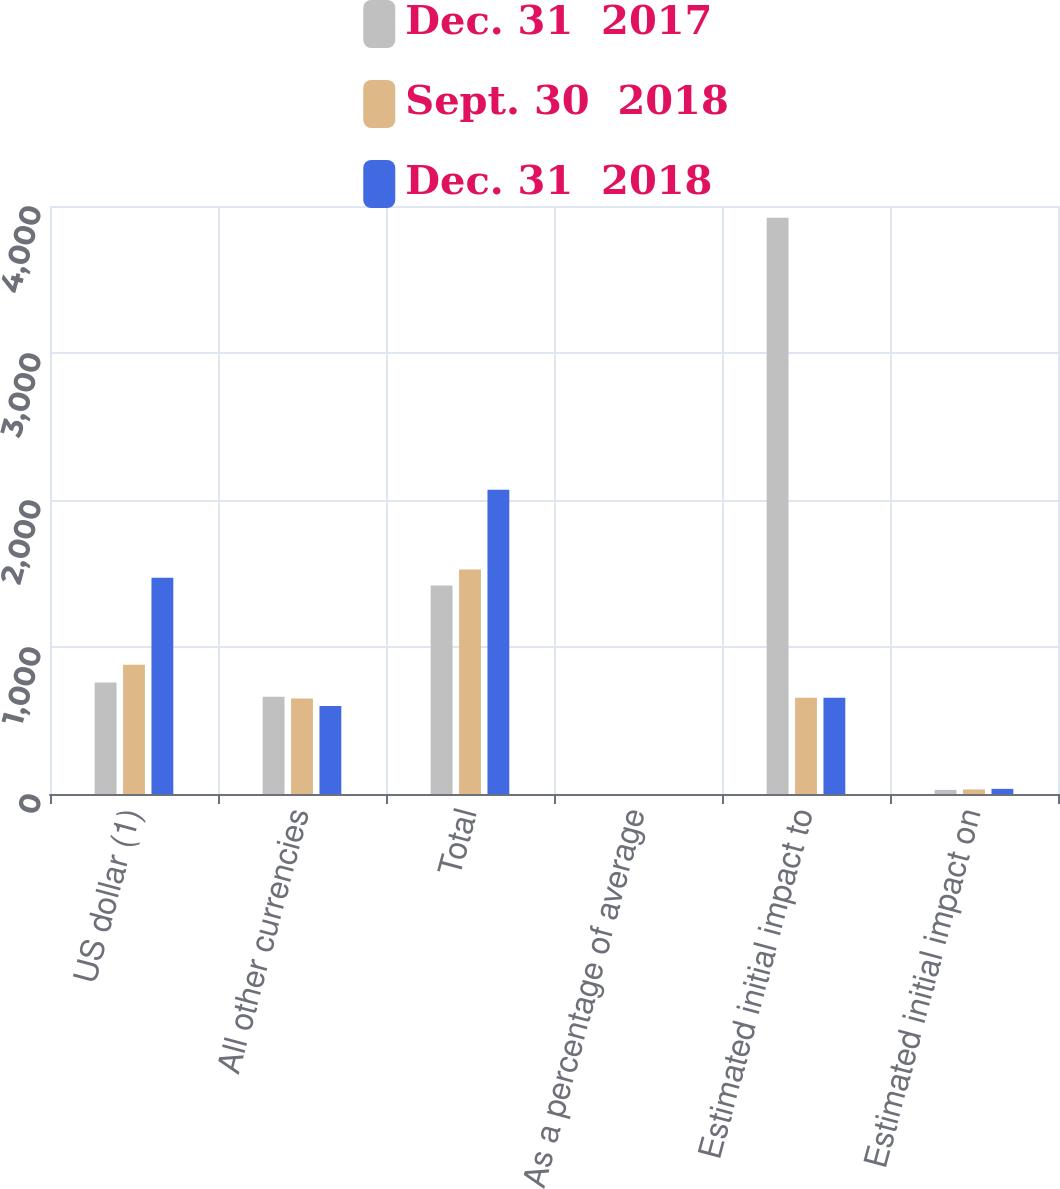Convert chart to OTSL. <chart><loc_0><loc_0><loc_500><loc_500><stacked_bar_chart><ecel><fcel>US dollar (1)<fcel>All other currencies<fcel>Total<fcel>As a percentage of average<fcel>Estimated initial impact to<fcel>Estimated initial impact on<nl><fcel>Dec. 31  2017<fcel>758<fcel>661<fcel>1419<fcel>0.08<fcel>3920<fcel>28<nl><fcel>Sept. 30  2018<fcel>879<fcel>649<fcel>1528<fcel>0.09<fcel>655<fcel>31<nl><fcel>Dec. 31  2018<fcel>1471<fcel>598<fcel>2069<fcel>0.12<fcel>655<fcel>35<nl></chart> 